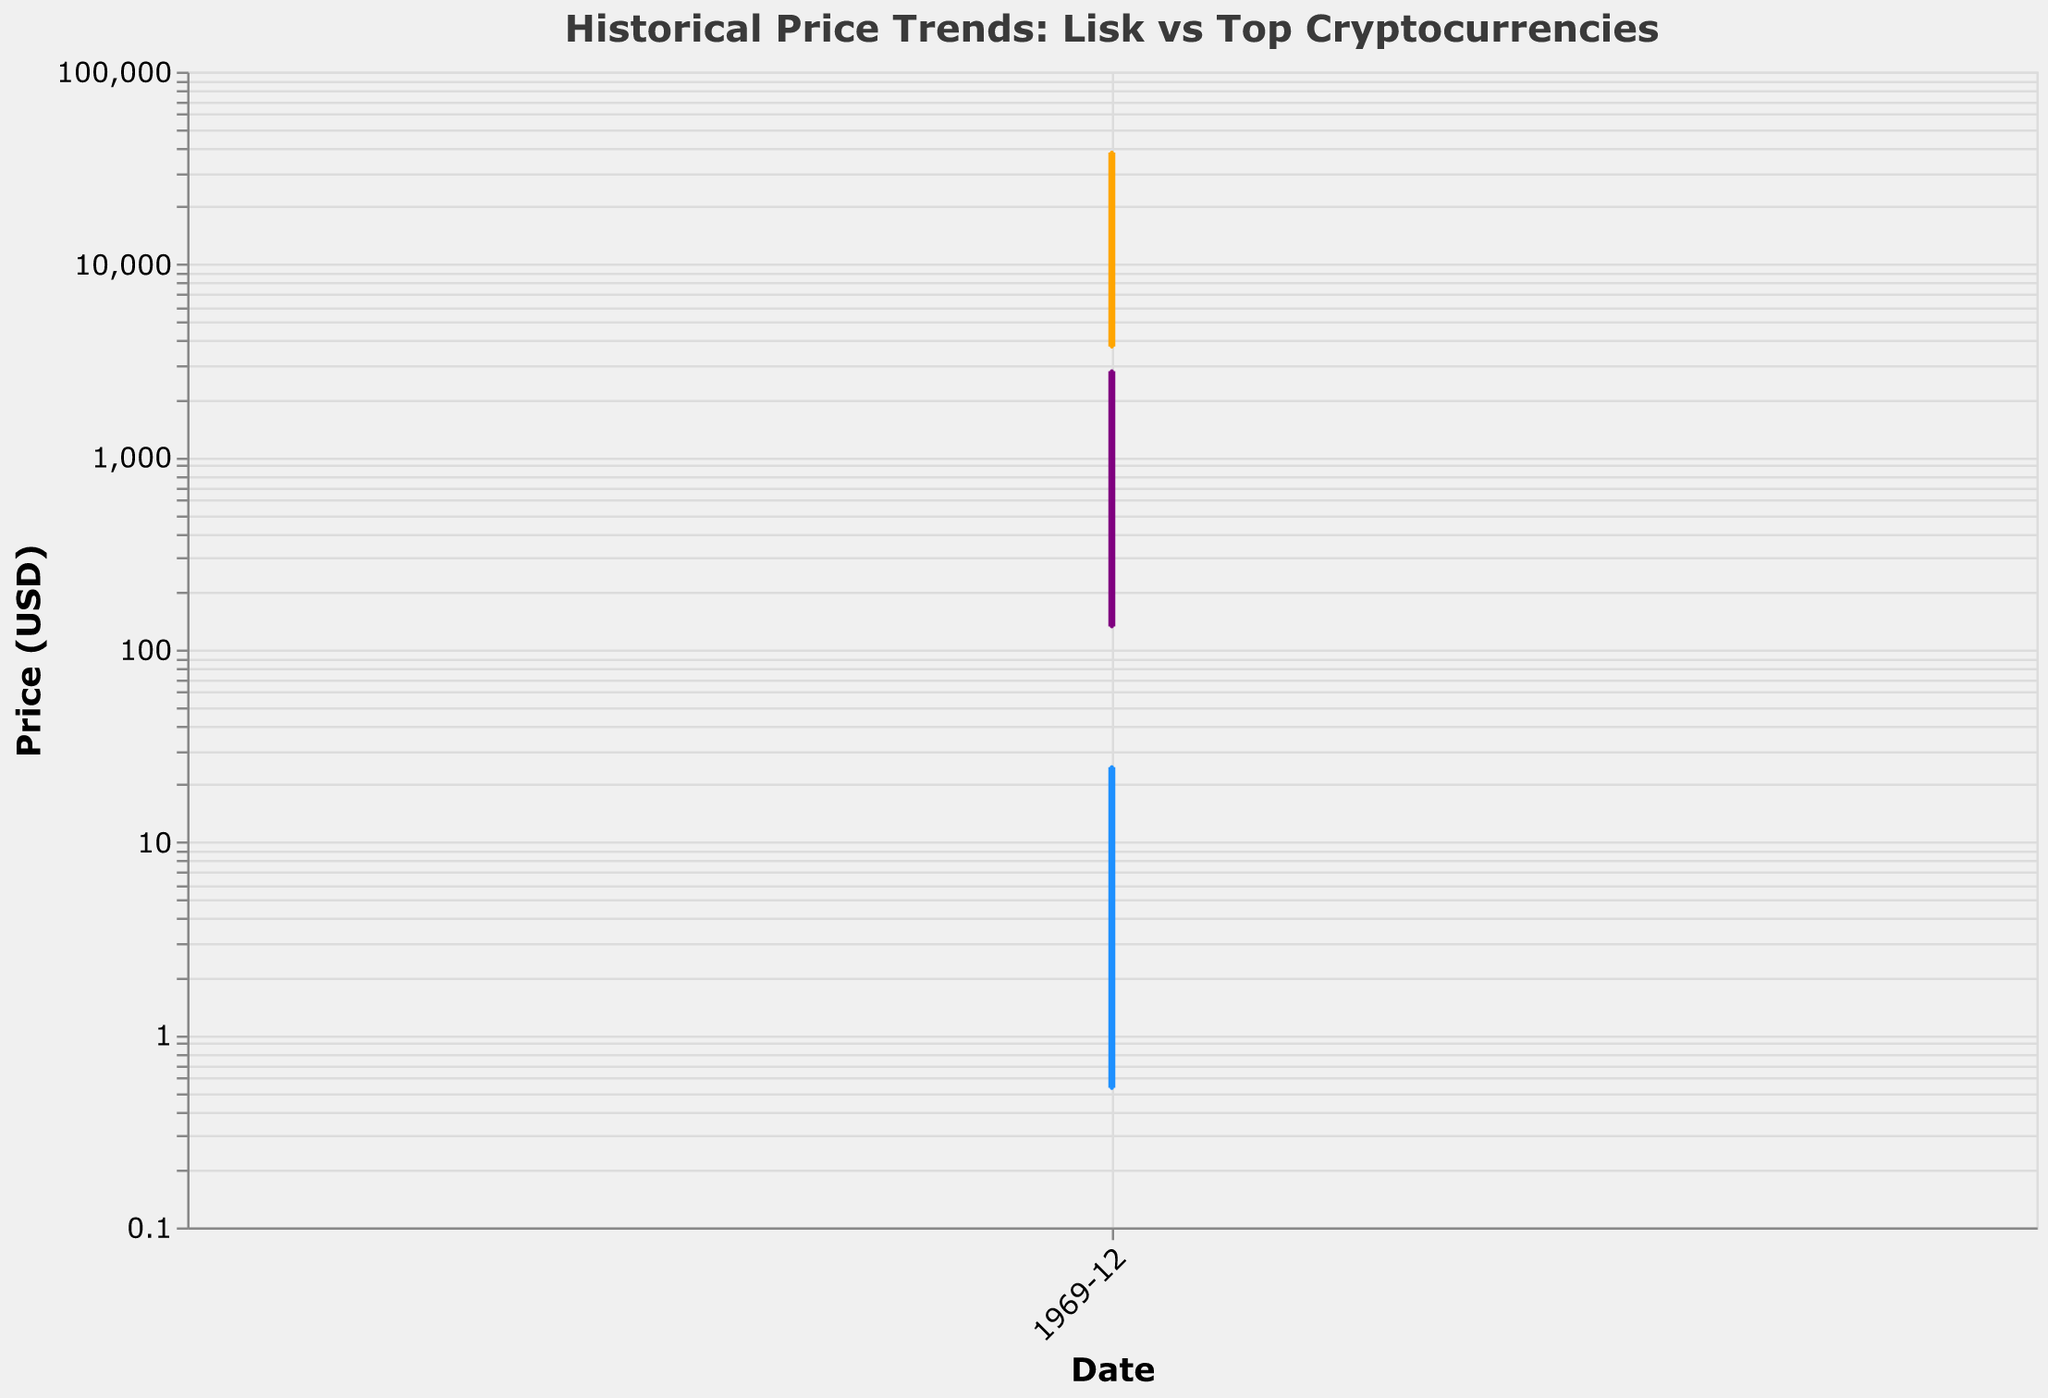What is the title of the plot? Look at the top of the figure to find the title, it usually describes the contents of the plot directly.
Answer: Historical Price Trends: Lisk vs Top Cryptocurrencies What colors represent Lisk, Bitcoin, and Ethereum in the plot? Examine the lines on the figure to see the corresponding colors for each cryptocurrency.
Answer: Lisk: Blue, Bitcoin: Orange, Ethereum: Purple How did the price of Lisk change from January 2018 to July 2018? Compare the data points for Lisk between January 2018 and July 2018. Note the shift in value.
Answer: Decreased from 24.50 to 4.25 Which cryptocurrency had the highest price in July 2023, and what was it? Locate the data points for July 2023 and compare the prices of all listed cryptocurrencies.
Answer: Bitcoin, 30475 When did Lisk have its lowest price in the provided data, and what was the price? Identify the minimum value data point for Lisk within the given date range.
Answer: January 2020, 0.53 How did the price of Bitcoin change between January 2022 and July 2022? Compare the price points of Bitcoin between January 2022 and July 2022. Note the direction and magnitude of change.
Answer: Decreased from 37989 to 19231 Which year and month had the maximum price for Ethereum, and what was it? Locate the peak price of Ethereum and note the corresponding date.
Answer: January 2022, 2782 Compare the general trends of Lisk and Ethereum from 2018 to 2023. How do their trends differ? Examine the overall plot lines of Lisk and Ethereum over the given period and note general patterns of increase or decrease.
Answer: Lisk fluctuates with no clear trend, Ethereum generally increases with more significant fluctuations How often did Lisk's price exceed $20 in the provided time period? Count the number of data points where the price of Lisk was above $20.
Answer: Once What was the trend in the price of Ripple (XRP) between January 2021 and January 2022? Compare and observe the changes in Ripple's price between January 2021 and January 2022.
Answer: Increased from 0.23 to 0.62 